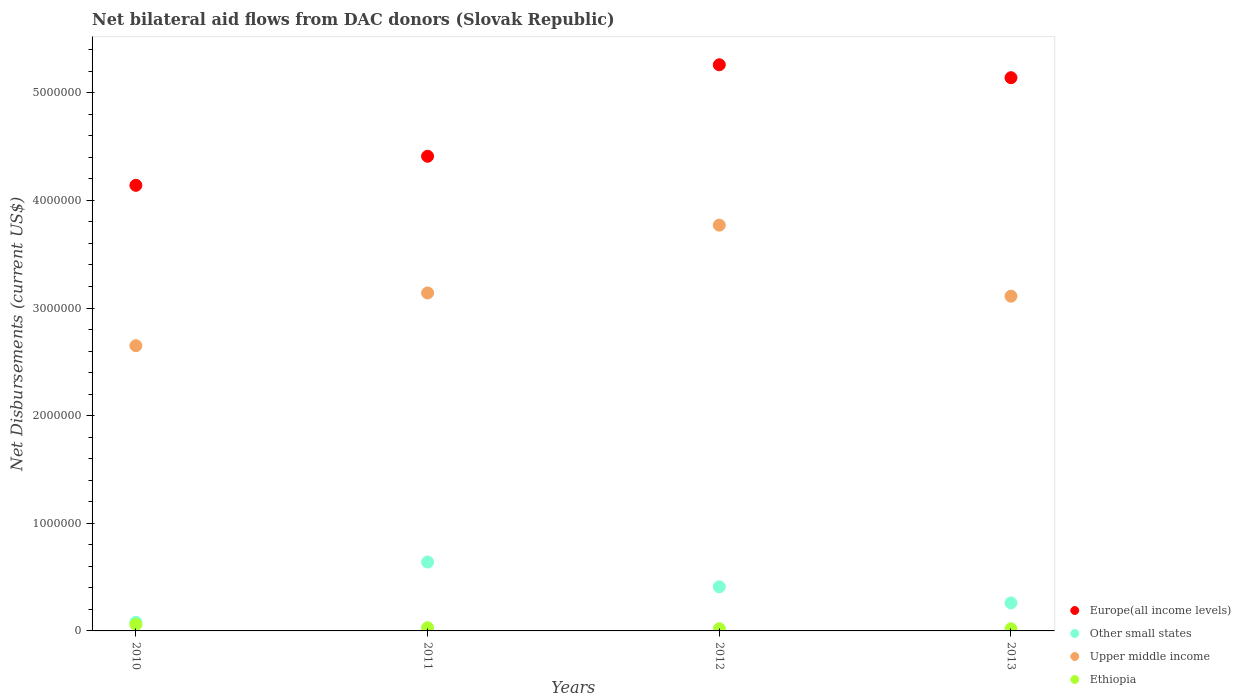Across all years, what is the maximum net bilateral aid flows in Other small states?
Your response must be concise. 6.40e+05. What is the total net bilateral aid flows in Other small states in the graph?
Your response must be concise. 1.39e+06. What is the difference between the net bilateral aid flows in Other small states in 2010 and that in 2011?
Give a very brief answer. -5.60e+05. What is the difference between the net bilateral aid flows in Other small states in 2013 and the net bilateral aid flows in Upper middle income in 2010?
Ensure brevity in your answer.  -2.39e+06. What is the average net bilateral aid flows in Other small states per year?
Your answer should be compact. 3.48e+05. In the year 2013, what is the difference between the net bilateral aid flows in Europe(all income levels) and net bilateral aid flows in Other small states?
Ensure brevity in your answer.  4.88e+06. In how many years, is the net bilateral aid flows in Ethiopia greater than 3600000 US$?
Provide a short and direct response. 0. What is the ratio of the net bilateral aid flows in Europe(all income levels) in 2011 to that in 2013?
Make the answer very short. 0.86. Is the net bilateral aid flows in Other small states in 2011 less than that in 2012?
Ensure brevity in your answer.  No. Is the difference between the net bilateral aid flows in Europe(all income levels) in 2011 and 2012 greater than the difference between the net bilateral aid flows in Other small states in 2011 and 2012?
Your response must be concise. No. What is the difference between the highest and the second highest net bilateral aid flows in Ethiopia?
Your answer should be very brief. 3.00e+04. What is the difference between the highest and the lowest net bilateral aid flows in Upper middle income?
Ensure brevity in your answer.  1.12e+06. In how many years, is the net bilateral aid flows in Europe(all income levels) greater than the average net bilateral aid flows in Europe(all income levels) taken over all years?
Keep it short and to the point. 2. Is the sum of the net bilateral aid flows in Upper middle income in 2011 and 2012 greater than the maximum net bilateral aid flows in Europe(all income levels) across all years?
Your answer should be compact. Yes. Is it the case that in every year, the sum of the net bilateral aid flows in Upper middle income and net bilateral aid flows in Other small states  is greater than the sum of net bilateral aid flows in Ethiopia and net bilateral aid flows in Europe(all income levels)?
Offer a very short reply. Yes. Is it the case that in every year, the sum of the net bilateral aid flows in Upper middle income and net bilateral aid flows in Other small states  is greater than the net bilateral aid flows in Europe(all income levels)?
Provide a short and direct response. No. Does the net bilateral aid flows in Other small states monotonically increase over the years?
Offer a very short reply. No. Is the net bilateral aid flows in Ethiopia strictly less than the net bilateral aid flows in Other small states over the years?
Your response must be concise. Yes. How many dotlines are there?
Provide a short and direct response. 4. What is the difference between two consecutive major ticks on the Y-axis?
Provide a succinct answer. 1.00e+06. Are the values on the major ticks of Y-axis written in scientific E-notation?
Keep it short and to the point. No. Does the graph contain grids?
Offer a very short reply. No. Where does the legend appear in the graph?
Give a very brief answer. Bottom right. What is the title of the graph?
Your answer should be compact. Net bilateral aid flows from DAC donors (Slovak Republic). Does "Libya" appear as one of the legend labels in the graph?
Your answer should be very brief. No. What is the label or title of the Y-axis?
Offer a terse response. Net Disbursements (current US$). What is the Net Disbursements (current US$) of Europe(all income levels) in 2010?
Your answer should be very brief. 4.14e+06. What is the Net Disbursements (current US$) in Upper middle income in 2010?
Provide a succinct answer. 2.65e+06. What is the Net Disbursements (current US$) of Ethiopia in 2010?
Ensure brevity in your answer.  6.00e+04. What is the Net Disbursements (current US$) of Europe(all income levels) in 2011?
Offer a terse response. 4.41e+06. What is the Net Disbursements (current US$) in Other small states in 2011?
Your answer should be compact. 6.40e+05. What is the Net Disbursements (current US$) in Upper middle income in 2011?
Provide a succinct answer. 3.14e+06. What is the Net Disbursements (current US$) of Europe(all income levels) in 2012?
Offer a terse response. 5.26e+06. What is the Net Disbursements (current US$) of Other small states in 2012?
Your response must be concise. 4.10e+05. What is the Net Disbursements (current US$) in Upper middle income in 2012?
Offer a very short reply. 3.77e+06. What is the Net Disbursements (current US$) in Ethiopia in 2012?
Offer a terse response. 2.00e+04. What is the Net Disbursements (current US$) in Europe(all income levels) in 2013?
Offer a very short reply. 5.14e+06. What is the Net Disbursements (current US$) in Upper middle income in 2013?
Make the answer very short. 3.11e+06. Across all years, what is the maximum Net Disbursements (current US$) of Europe(all income levels)?
Make the answer very short. 5.26e+06. Across all years, what is the maximum Net Disbursements (current US$) of Other small states?
Offer a very short reply. 6.40e+05. Across all years, what is the maximum Net Disbursements (current US$) of Upper middle income?
Keep it short and to the point. 3.77e+06. Across all years, what is the minimum Net Disbursements (current US$) of Europe(all income levels)?
Provide a short and direct response. 4.14e+06. Across all years, what is the minimum Net Disbursements (current US$) of Upper middle income?
Offer a terse response. 2.65e+06. What is the total Net Disbursements (current US$) of Europe(all income levels) in the graph?
Make the answer very short. 1.90e+07. What is the total Net Disbursements (current US$) of Other small states in the graph?
Make the answer very short. 1.39e+06. What is the total Net Disbursements (current US$) in Upper middle income in the graph?
Provide a succinct answer. 1.27e+07. What is the total Net Disbursements (current US$) in Ethiopia in the graph?
Your response must be concise. 1.30e+05. What is the difference between the Net Disbursements (current US$) of Other small states in 2010 and that in 2011?
Your answer should be compact. -5.60e+05. What is the difference between the Net Disbursements (current US$) of Upper middle income in 2010 and that in 2011?
Offer a very short reply. -4.90e+05. What is the difference between the Net Disbursements (current US$) in Europe(all income levels) in 2010 and that in 2012?
Your answer should be compact. -1.12e+06. What is the difference between the Net Disbursements (current US$) in Other small states in 2010 and that in 2012?
Ensure brevity in your answer.  -3.30e+05. What is the difference between the Net Disbursements (current US$) in Upper middle income in 2010 and that in 2012?
Make the answer very short. -1.12e+06. What is the difference between the Net Disbursements (current US$) in Upper middle income in 2010 and that in 2013?
Your answer should be very brief. -4.60e+05. What is the difference between the Net Disbursements (current US$) of Europe(all income levels) in 2011 and that in 2012?
Your answer should be very brief. -8.50e+05. What is the difference between the Net Disbursements (current US$) of Other small states in 2011 and that in 2012?
Your response must be concise. 2.30e+05. What is the difference between the Net Disbursements (current US$) of Upper middle income in 2011 and that in 2012?
Give a very brief answer. -6.30e+05. What is the difference between the Net Disbursements (current US$) of Europe(all income levels) in 2011 and that in 2013?
Your answer should be very brief. -7.30e+05. What is the difference between the Net Disbursements (current US$) in Ethiopia in 2011 and that in 2013?
Make the answer very short. 10000. What is the difference between the Net Disbursements (current US$) of Other small states in 2012 and that in 2013?
Your answer should be compact. 1.50e+05. What is the difference between the Net Disbursements (current US$) in Ethiopia in 2012 and that in 2013?
Offer a terse response. 0. What is the difference between the Net Disbursements (current US$) in Europe(all income levels) in 2010 and the Net Disbursements (current US$) in Other small states in 2011?
Provide a short and direct response. 3.50e+06. What is the difference between the Net Disbursements (current US$) of Europe(all income levels) in 2010 and the Net Disbursements (current US$) of Upper middle income in 2011?
Your answer should be very brief. 1.00e+06. What is the difference between the Net Disbursements (current US$) of Europe(all income levels) in 2010 and the Net Disbursements (current US$) of Ethiopia in 2011?
Offer a terse response. 4.11e+06. What is the difference between the Net Disbursements (current US$) in Other small states in 2010 and the Net Disbursements (current US$) in Upper middle income in 2011?
Provide a succinct answer. -3.06e+06. What is the difference between the Net Disbursements (current US$) in Upper middle income in 2010 and the Net Disbursements (current US$) in Ethiopia in 2011?
Ensure brevity in your answer.  2.62e+06. What is the difference between the Net Disbursements (current US$) in Europe(all income levels) in 2010 and the Net Disbursements (current US$) in Other small states in 2012?
Provide a succinct answer. 3.73e+06. What is the difference between the Net Disbursements (current US$) in Europe(all income levels) in 2010 and the Net Disbursements (current US$) in Upper middle income in 2012?
Ensure brevity in your answer.  3.70e+05. What is the difference between the Net Disbursements (current US$) of Europe(all income levels) in 2010 and the Net Disbursements (current US$) of Ethiopia in 2012?
Give a very brief answer. 4.12e+06. What is the difference between the Net Disbursements (current US$) of Other small states in 2010 and the Net Disbursements (current US$) of Upper middle income in 2012?
Offer a terse response. -3.69e+06. What is the difference between the Net Disbursements (current US$) of Upper middle income in 2010 and the Net Disbursements (current US$) of Ethiopia in 2012?
Your response must be concise. 2.63e+06. What is the difference between the Net Disbursements (current US$) in Europe(all income levels) in 2010 and the Net Disbursements (current US$) in Other small states in 2013?
Keep it short and to the point. 3.88e+06. What is the difference between the Net Disbursements (current US$) in Europe(all income levels) in 2010 and the Net Disbursements (current US$) in Upper middle income in 2013?
Offer a terse response. 1.03e+06. What is the difference between the Net Disbursements (current US$) in Europe(all income levels) in 2010 and the Net Disbursements (current US$) in Ethiopia in 2013?
Your answer should be very brief. 4.12e+06. What is the difference between the Net Disbursements (current US$) in Other small states in 2010 and the Net Disbursements (current US$) in Upper middle income in 2013?
Offer a terse response. -3.03e+06. What is the difference between the Net Disbursements (current US$) of Upper middle income in 2010 and the Net Disbursements (current US$) of Ethiopia in 2013?
Provide a succinct answer. 2.63e+06. What is the difference between the Net Disbursements (current US$) of Europe(all income levels) in 2011 and the Net Disbursements (current US$) of Upper middle income in 2012?
Provide a succinct answer. 6.40e+05. What is the difference between the Net Disbursements (current US$) of Europe(all income levels) in 2011 and the Net Disbursements (current US$) of Ethiopia in 2012?
Your answer should be compact. 4.39e+06. What is the difference between the Net Disbursements (current US$) in Other small states in 2011 and the Net Disbursements (current US$) in Upper middle income in 2012?
Give a very brief answer. -3.13e+06. What is the difference between the Net Disbursements (current US$) of Other small states in 2011 and the Net Disbursements (current US$) of Ethiopia in 2012?
Keep it short and to the point. 6.20e+05. What is the difference between the Net Disbursements (current US$) of Upper middle income in 2011 and the Net Disbursements (current US$) of Ethiopia in 2012?
Make the answer very short. 3.12e+06. What is the difference between the Net Disbursements (current US$) of Europe(all income levels) in 2011 and the Net Disbursements (current US$) of Other small states in 2013?
Give a very brief answer. 4.15e+06. What is the difference between the Net Disbursements (current US$) of Europe(all income levels) in 2011 and the Net Disbursements (current US$) of Upper middle income in 2013?
Provide a short and direct response. 1.30e+06. What is the difference between the Net Disbursements (current US$) of Europe(all income levels) in 2011 and the Net Disbursements (current US$) of Ethiopia in 2013?
Ensure brevity in your answer.  4.39e+06. What is the difference between the Net Disbursements (current US$) in Other small states in 2011 and the Net Disbursements (current US$) in Upper middle income in 2013?
Provide a succinct answer. -2.47e+06. What is the difference between the Net Disbursements (current US$) in Other small states in 2011 and the Net Disbursements (current US$) in Ethiopia in 2013?
Provide a short and direct response. 6.20e+05. What is the difference between the Net Disbursements (current US$) in Upper middle income in 2011 and the Net Disbursements (current US$) in Ethiopia in 2013?
Your response must be concise. 3.12e+06. What is the difference between the Net Disbursements (current US$) in Europe(all income levels) in 2012 and the Net Disbursements (current US$) in Other small states in 2013?
Offer a very short reply. 5.00e+06. What is the difference between the Net Disbursements (current US$) in Europe(all income levels) in 2012 and the Net Disbursements (current US$) in Upper middle income in 2013?
Provide a short and direct response. 2.15e+06. What is the difference between the Net Disbursements (current US$) of Europe(all income levels) in 2012 and the Net Disbursements (current US$) of Ethiopia in 2013?
Keep it short and to the point. 5.24e+06. What is the difference between the Net Disbursements (current US$) of Other small states in 2012 and the Net Disbursements (current US$) of Upper middle income in 2013?
Your answer should be very brief. -2.70e+06. What is the difference between the Net Disbursements (current US$) in Upper middle income in 2012 and the Net Disbursements (current US$) in Ethiopia in 2013?
Your response must be concise. 3.75e+06. What is the average Net Disbursements (current US$) in Europe(all income levels) per year?
Provide a succinct answer. 4.74e+06. What is the average Net Disbursements (current US$) in Other small states per year?
Offer a terse response. 3.48e+05. What is the average Net Disbursements (current US$) of Upper middle income per year?
Your answer should be very brief. 3.17e+06. What is the average Net Disbursements (current US$) in Ethiopia per year?
Make the answer very short. 3.25e+04. In the year 2010, what is the difference between the Net Disbursements (current US$) of Europe(all income levels) and Net Disbursements (current US$) of Other small states?
Give a very brief answer. 4.06e+06. In the year 2010, what is the difference between the Net Disbursements (current US$) in Europe(all income levels) and Net Disbursements (current US$) in Upper middle income?
Your answer should be compact. 1.49e+06. In the year 2010, what is the difference between the Net Disbursements (current US$) of Europe(all income levels) and Net Disbursements (current US$) of Ethiopia?
Offer a terse response. 4.08e+06. In the year 2010, what is the difference between the Net Disbursements (current US$) of Other small states and Net Disbursements (current US$) of Upper middle income?
Make the answer very short. -2.57e+06. In the year 2010, what is the difference between the Net Disbursements (current US$) in Upper middle income and Net Disbursements (current US$) in Ethiopia?
Offer a very short reply. 2.59e+06. In the year 2011, what is the difference between the Net Disbursements (current US$) of Europe(all income levels) and Net Disbursements (current US$) of Other small states?
Your answer should be compact. 3.77e+06. In the year 2011, what is the difference between the Net Disbursements (current US$) of Europe(all income levels) and Net Disbursements (current US$) of Upper middle income?
Your response must be concise. 1.27e+06. In the year 2011, what is the difference between the Net Disbursements (current US$) of Europe(all income levels) and Net Disbursements (current US$) of Ethiopia?
Give a very brief answer. 4.38e+06. In the year 2011, what is the difference between the Net Disbursements (current US$) of Other small states and Net Disbursements (current US$) of Upper middle income?
Provide a succinct answer. -2.50e+06. In the year 2011, what is the difference between the Net Disbursements (current US$) of Other small states and Net Disbursements (current US$) of Ethiopia?
Your response must be concise. 6.10e+05. In the year 2011, what is the difference between the Net Disbursements (current US$) in Upper middle income and Net Disbursements (current US$) in Ethiopia?
Provide a short and direct response. 3.11e+06. In the year 2012, what is the difference between the Net Disbursements (current US$) of Europe(all income levels) and Net Disbursements (current US$) of Other small states?
Your answer should be very brief. 4.85e+06. In the year 2012, what is the difference between the Net Disbursements (current US$) in Europe(all income levels) and Net Disbursements (current US$) in Upper middle income?
Give a very brief answer. 1.49e+06. In the year 2012, what is the difference between the Net Disbursements (current US$) in Europe(all income levels) and Net Disbursements (current US$) in Ethiopia?
Make the answer very short. 5.24e+06. In the year 2012, what is the difference between the Net Disbursements (current US$) in Other small states and Net Disbursements (current US$) in Upper middle income?
Offer a terse response. -3.36e+06. In the year 2012, what is the difference between the Net Disbursements (current US$) of Other small states and Net Disbursements (current US$) of Ethiopia?
Offer a terse response. 3.90e+05. In the year 2012, what is the difference between the Net Disbursements (current US$) of Upper middle income and Net Disbursements (current US$) of Ethiopia?
Offer a terse response. 3.75e+06. In the year 2013, what is the difference between the Net Disbursements (current US$) of Europe(all income levels) and Net Disbursements (current US$) of Other small states?
Offer a terse response. 4.88e+06. In the year 2013, what is the difference between the Net Disbursements (current US$) of Europe(all income levels) and Net Disbursements (current US$) of Upper middle income?
Make the answer very short. 2.03e+06. In the year 2013, what is the difference between the Net Disbursements (current US$) in Europe(all income levels) and Net Disbursements (current US$) in Ethiopia?
Your answer should be compact. 5.12e+06. In the year 2013, what is the difference between the Net Disbursements (current US$) of Other small states and Net Disbursements (current US$) of Upper middle income?
Give a very brief answer. -2.85e+06. In the year 2013, what is the difference between the Net Disbursements (current US$) of Upper middle income and Net Disbursements (current US$) of Ethiopia?
Your answer should be very brief. 3.09e+06. What is the ratio of the Net Disbursements (current US$) in Europe(all income levels) in 2010 to that in 2011?
Provide a succinct answer. 0.94. What is the ratio of the Net Disbursements (current US$) in Other small states in 2010 to that in 2011?
Provide a short and direct response. 0.12. What is the ratio of the Net Disbursements (current US$) in Upper middle income in 2010 to that in 2011?
Make the answer very short. 0.84. What is the ratio of the Net Disbursements (current US$) of Europe(all income levels) in 2010 to that in 2012?
Ensure brevity in your answer.  0.79. What is the ratio of the Net Disbursements (current US$) of Other small states in 2010 to that in 2012?
Provide a succinct answer. 0.2. What is the ratio of the Net Disbursements (current US$) of Upper middle income in 2010 to that in 2012?
Offer a very short reply. 0.7. What is the ratio of the Net Disbursements (current US$) of Ethiopia in 2010 to that in 2012?
Keep it short and to the point. 3. What is the ratio of the Net Disbursements (current US$) of Europe(all income levels) in 2010 to that in 2013?
Make the answer very short. 0.81. What is the ratio of the Net Disbursements (current US$) of Other small states in 2010 to that in 2013?
Provide a short and direct response. 0.31. What is the ratio of the Net Disbursements (current US$) in Upper middle income in 2010 to that in 2013?
Your response must be concise. 0.85. What is the ratio of the Net Disbursements (current US$) of Europe(all income levels) in 2011 to that in 2012?
Keep it short and to the point. 0.84. What is the ratio of the Net Disbursements (current US$) of Other small states in 2011 to that in 2012?
Provide a short and direct response. 1.56. What is the ratio of the Net Disbursements (current US$) in Upper middle income in 2011 to that in 2012?
Offer a very short reply. 0.83. What is the ratio of the Net Disbursements (current US$) of Ethiopia in 2011 to that in 2012?
Offer a very short reply. 1.5. What is the ratio of the Net Disbursements (current US$) of Europe(all income levels) in 2011 to that in 2013?
Ensure brevity in your answer.  0.86. What is the ratio of the Net Disbursements (current US$) of Other small states in 2011 to that in 2013?
Keep it short and to the point. 2.46. What is the ratio of the Net Disbursements (current US$) of Upper middle income in 2011 to that in 2013?
Offer a terse response. 1.01. What is the ratio of the Net Disbursements (current US$) of Ethiopia in 2011 to that in 2013?
Make the answer very short. 1.5. What is the ratio of the Net Disbursements (current US$) of Europe(all income levels) in 2012 to that in 2013?
Make the answer very short. 1.02. What is the ratio of the Net Disbursements (current US$) in Other small states in 2012 to that in 2013?
Your response must be concise. 1.58. What is the ratio of the Net Disbursements (current US$) in Upper middle income in 2012 to that in 2013?
Your answer should be compact. 1.21. What is the ratio of the Net Disbursements (current US$) of Ethiopia in 2012 to that in 2013?
Offer a very short reply. 1. What is the difference between the highest and the second highest Net Disbursements (current US$) of Europe(all income levels)?
Your response must be concise. 1.20e+05. What is the difference between the highest and the second highest Net Disbursements (current US$) of Other small states?
Your response must be concise. 2.30e+05. What is the difference between the highest and the second highest Net Disbursements (current US$) of Upper middle income?
Give a very brief answer. 6.30e+05. What is the difference between the highest and the second highest Net Disbursements (current US$) in Ethiopia?
Give a very brief answer. 3.00e+04. What is the difference between the highest and the lowest Net Disbursements (current US$) in Europe(all income levels)?
Your answer should be very brief. 1.12e+06. What is the difference between the highest and the lowest Net Disbursements (current US$) in Other small states?
Offer a very short reply. 5.60e+05. What is the difference between the highest and the lowest Net Disbursements (current US$) of Upper middle income?
Give a very brief answer. 1.12e+06. What is the difference between the highest and the lowest Net Disbursements (current US$) in Ethiopia?
Your response must be concise. 4.00e+04. 